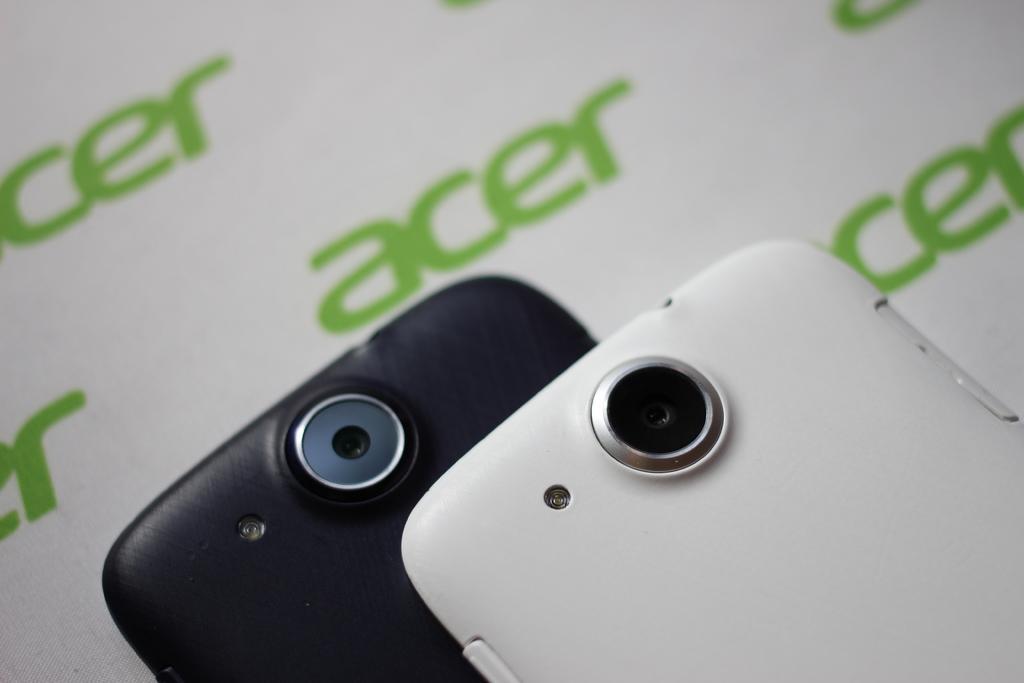Can you describe this image briefly? In the image there are two mobile phones. 